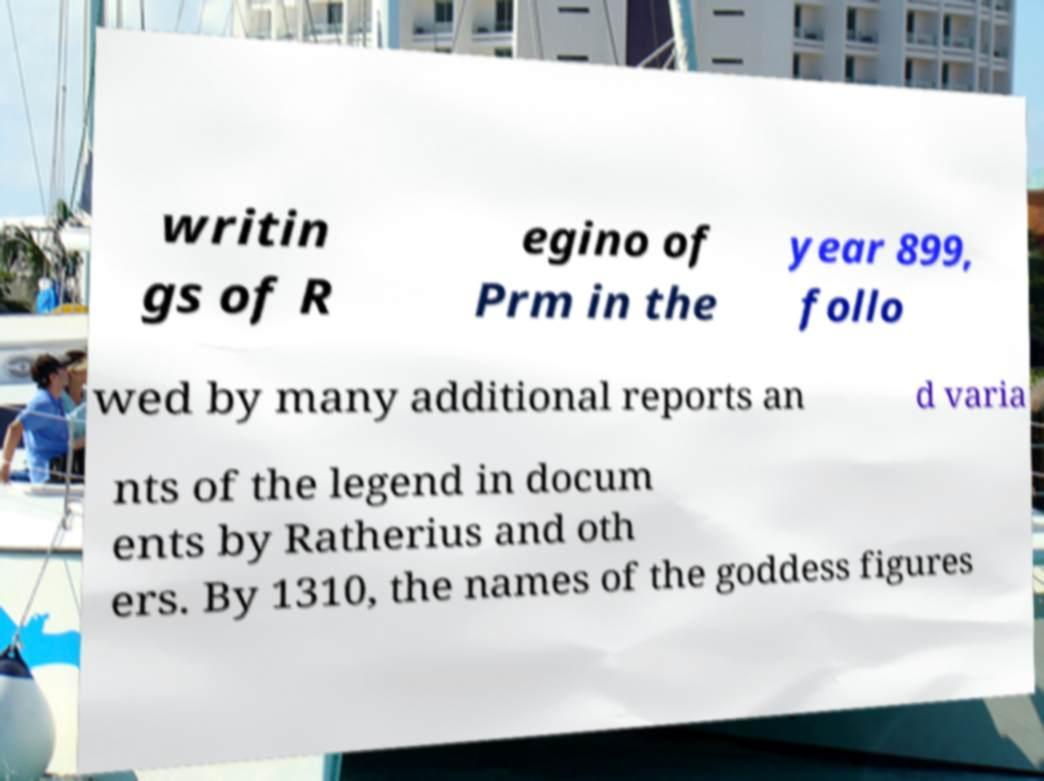What messages or text are displayed in this image? I need them in a readable, typed format. writin gs of R egino of Prm in the year 899, follo wed by many additional reports an d varia nts of the legend in docum ents by Ratherius and oth ers. By 1310, the names of the goddess figures 